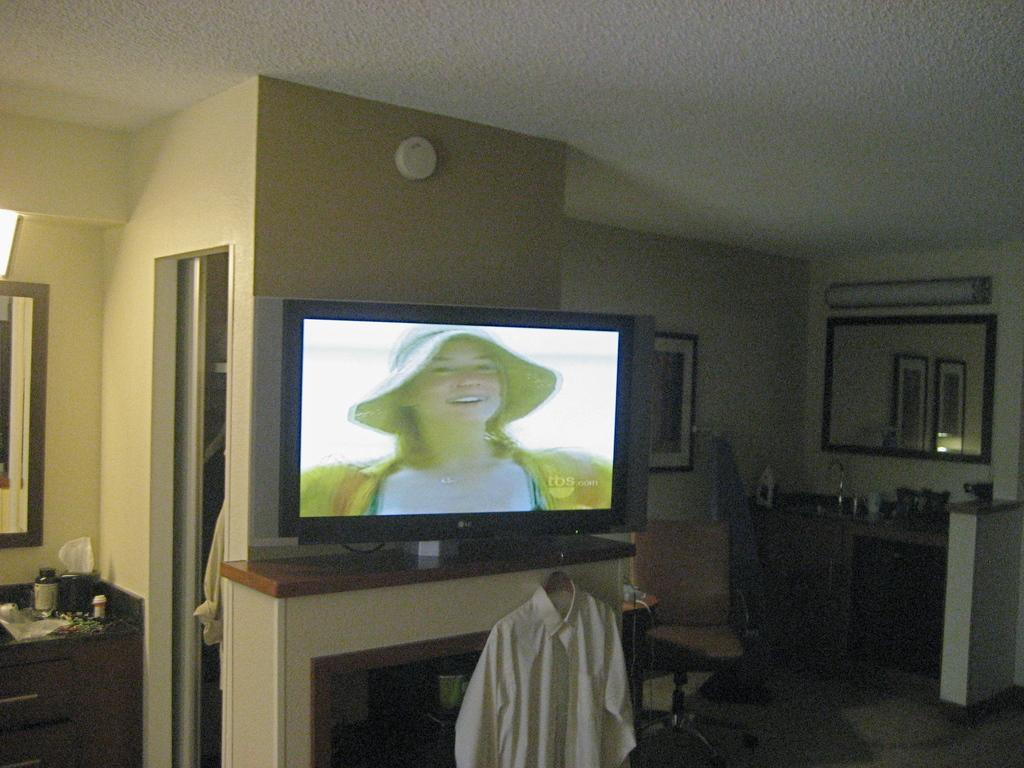What type of structure can be seen in the image? There is a wall in the image. What decorative item is present on the wall? There is a photo frame in the image. What is used for reflecting images in the image? There is a mirror in the image. What provides illumination in the image? There are lights in the image. What allows natural light to enter the space in the image? There is a window in the image. What type of electronic device is present in the image? There is a television in the image. What type of fabric is present in the image? There is cloth in the image. What piece of furniture is present in the image? There is a table in the image. How many horses are visible in the image? There are no horses present in the image. What type of clock is featured on the wall in the image? There is no clock present in the image. 